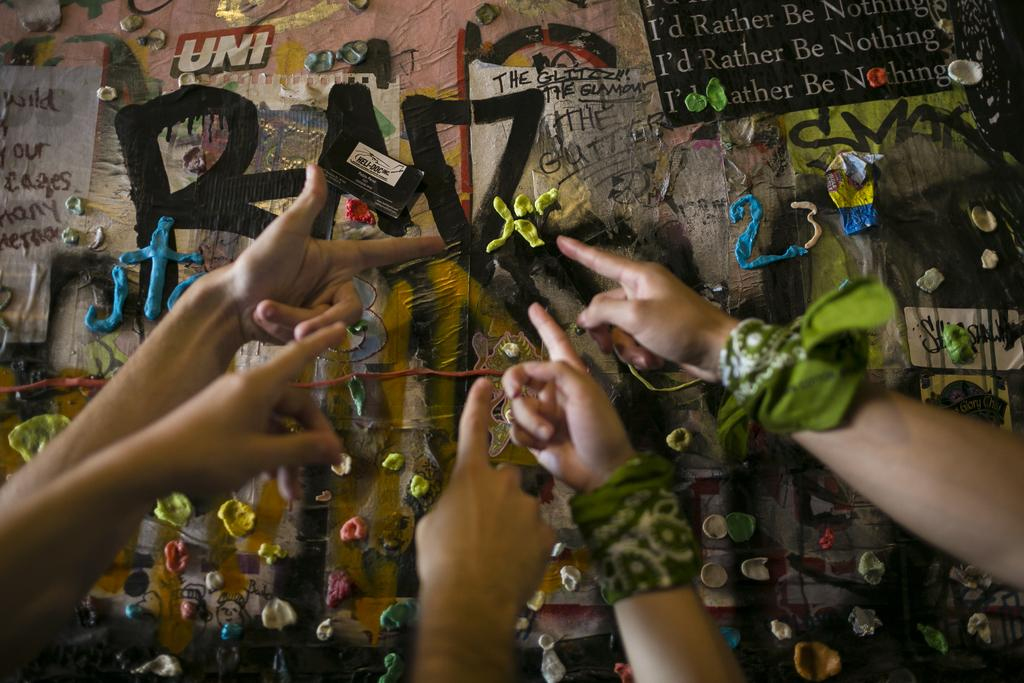What is the main subject in the center of the image? There are hands in the center of the image. What is depicted on the poster in the image? There is clay on a poster in the image. What type of jelly can be seen on the hands in the image? There is no jelly present on the hands in the image; they are holding clay. How many birds are visible on the poster in the image? There are no birds depicted on the poster in the image; it features clay. 